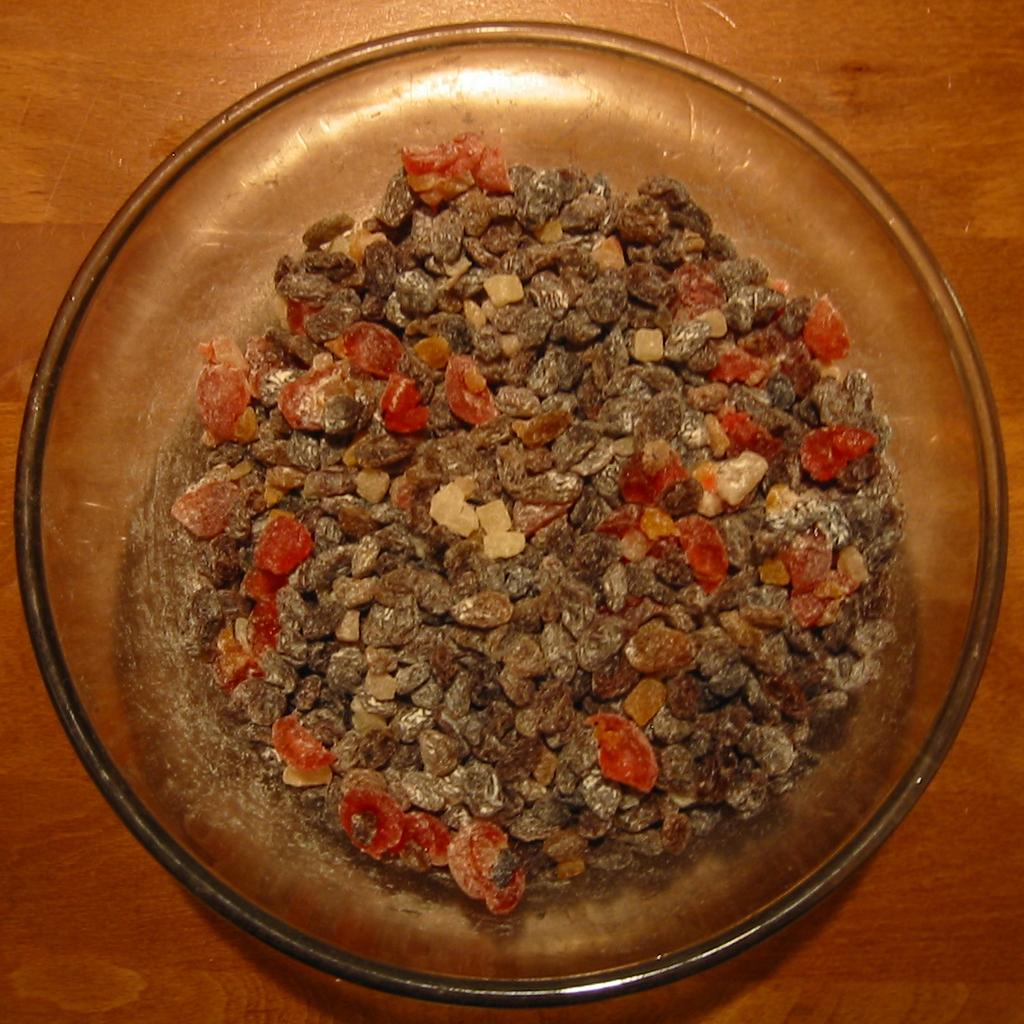What is in the bowl that is visible in the image? There are objects in a bowl in the image. Where is the bowl located in the image? The bowl is on a table in the image. How many ladybugs are playing chess on the table in the image? There are no ladybugs or chess games present in the image. 